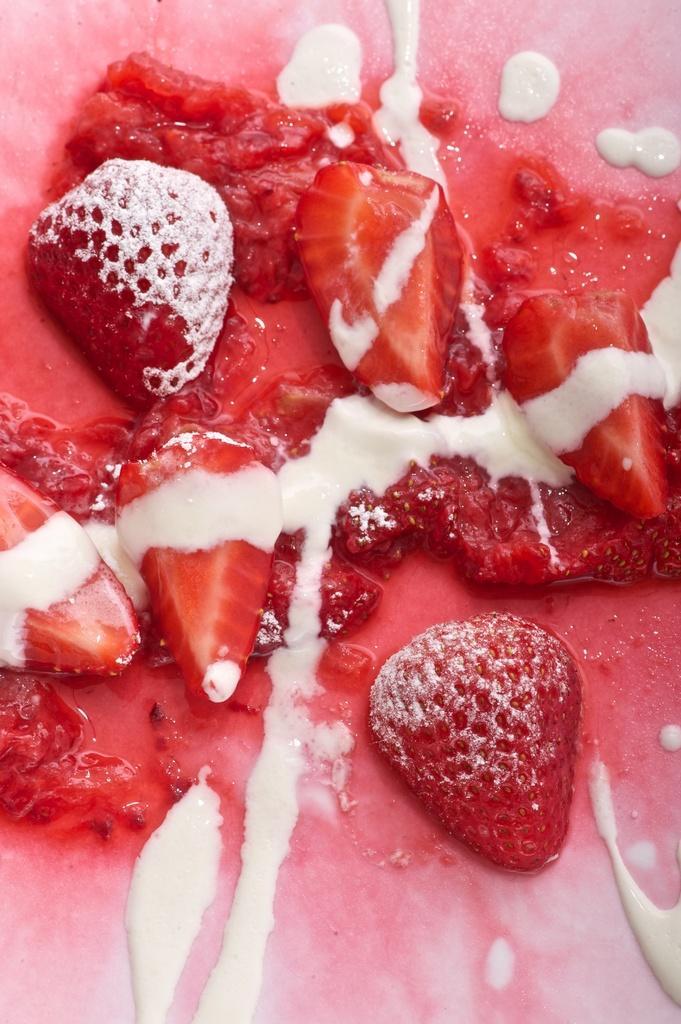Could you give a brief overview of what you see in this image? In the image we can see the food item, like strawberries and white cream. 